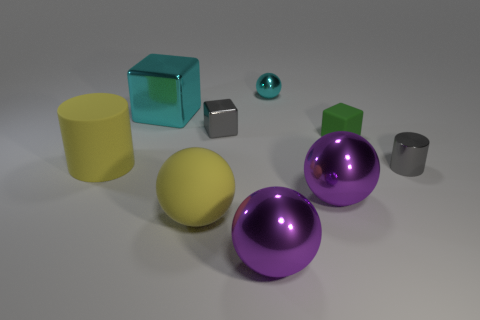There is a metallic ball that is the same color as the large shiny cube; what size is it?
Give a very brief answer. Small. What material is the cylinder to the right of the yellow object that is on the right side of the large cylinder?
Offer a terse response. Metal. There is a large cyan thing that is the same shape as the small matte object; what material is it?
Offer a very short reply. Metal. There is a gray thing to the left of the gray shiny thing that is on the right side of the gray shiny block; are there any cyan shiny cubes in front of it?
Offer a terse response. No. How many other things are the same color as the small cylinder?
Provide a short and direct response. 1. What number of things are both left of the rubber block and on the right side of the small cyan thing?
Your answer should be compact. 1. What shape is the tiny cyan metallic thing?
Offer a very short reply. Sphere. What number of other objects are the same material as the tiny green block?
Provide a short and direct response. 2. The cube that is on the right side of the tiny gray shiny object behind the tiny gray metal thing in front of the small green matte cube is what color?
Keep it short and to the point. Green. What is the material of the other cube that is the same size as the gray metallic block?
Ensure brevity in your answer.  Rubber. 